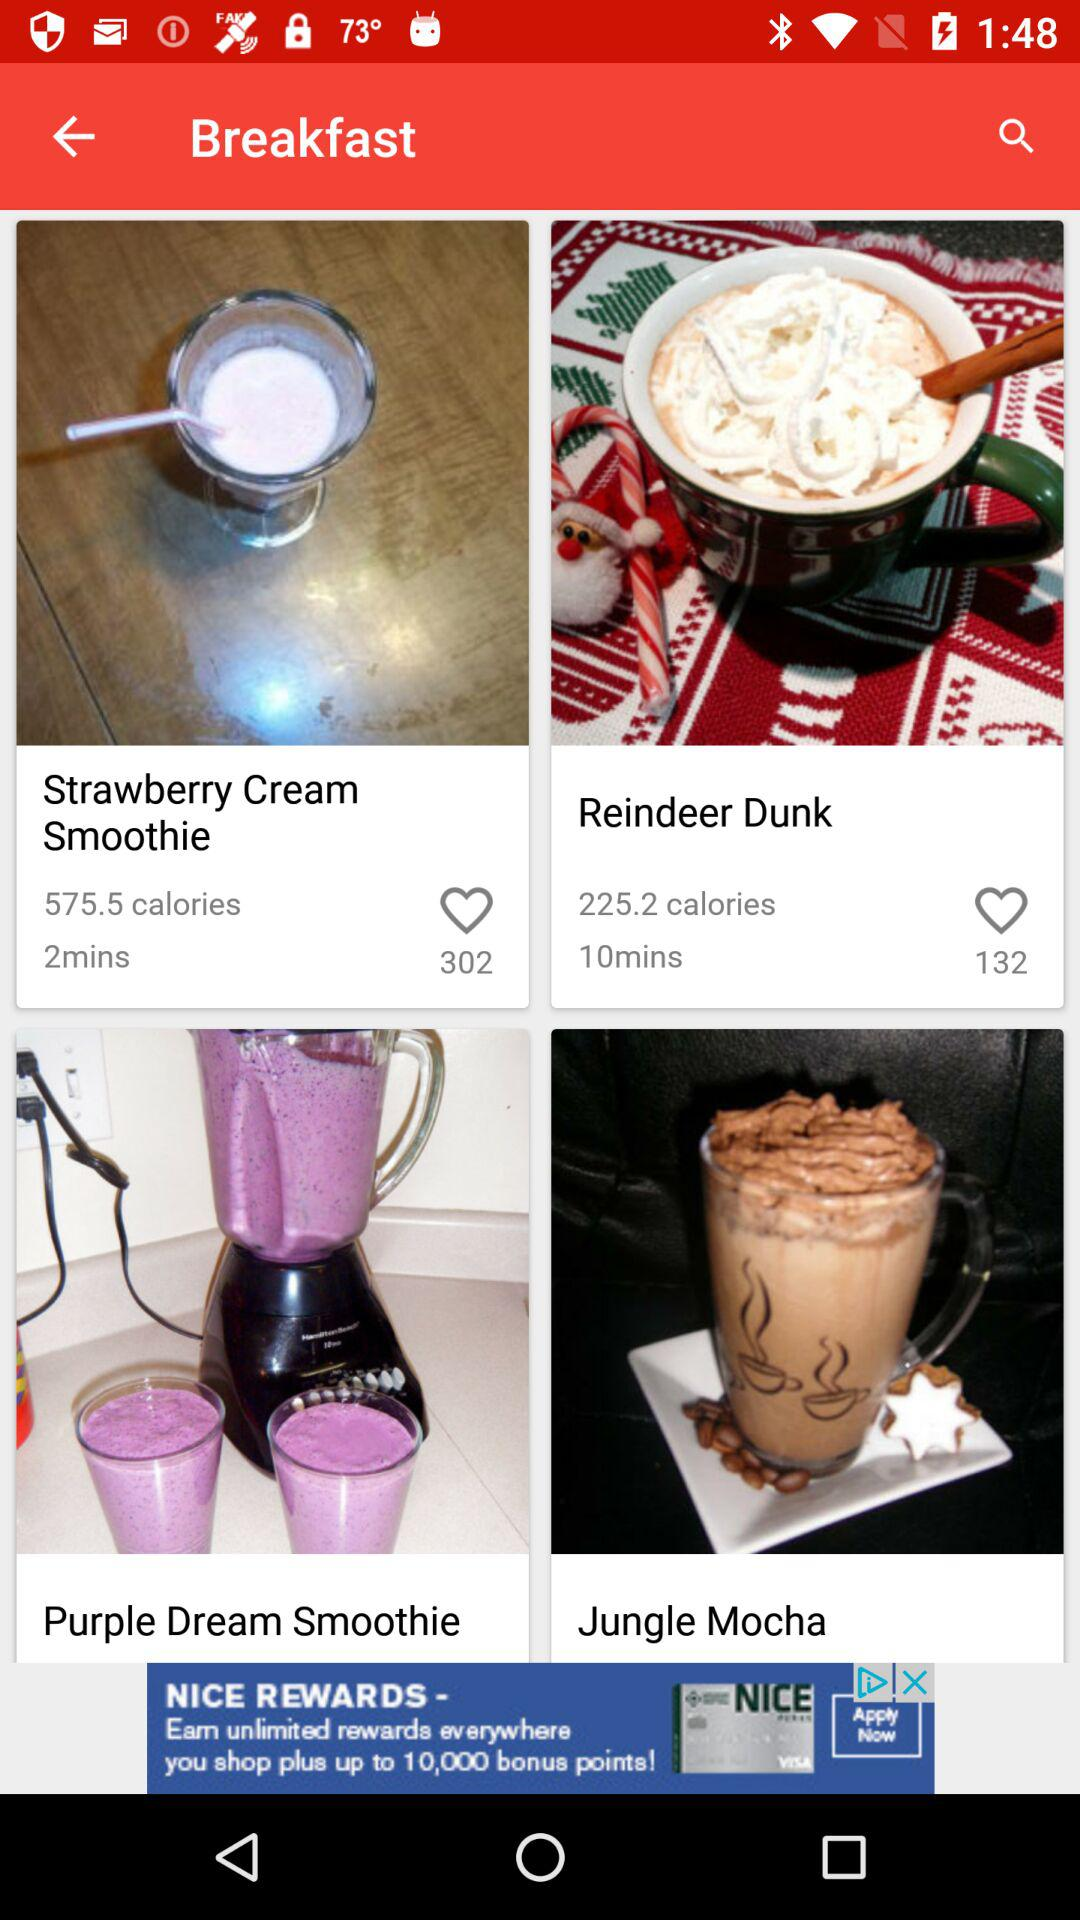How many calories are in "Strawberry Cream Smoothie"? There are 575.5 calories in "Strawberry Cream Smoothie". 